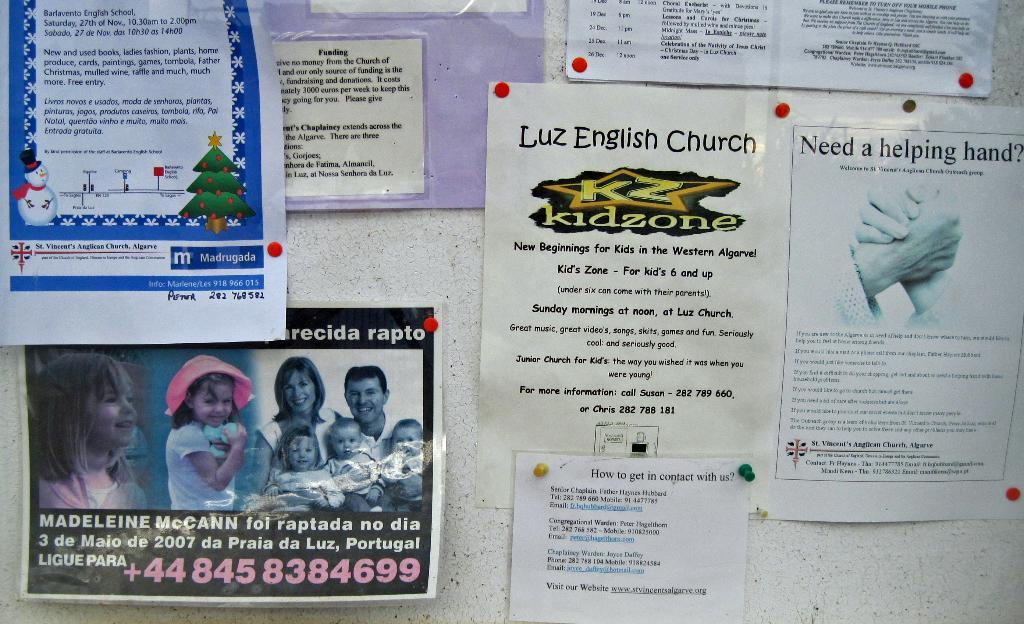<image>
Present a compact description of the photo's key features. A bulletin board with a flyer for Luz English Church on it. 